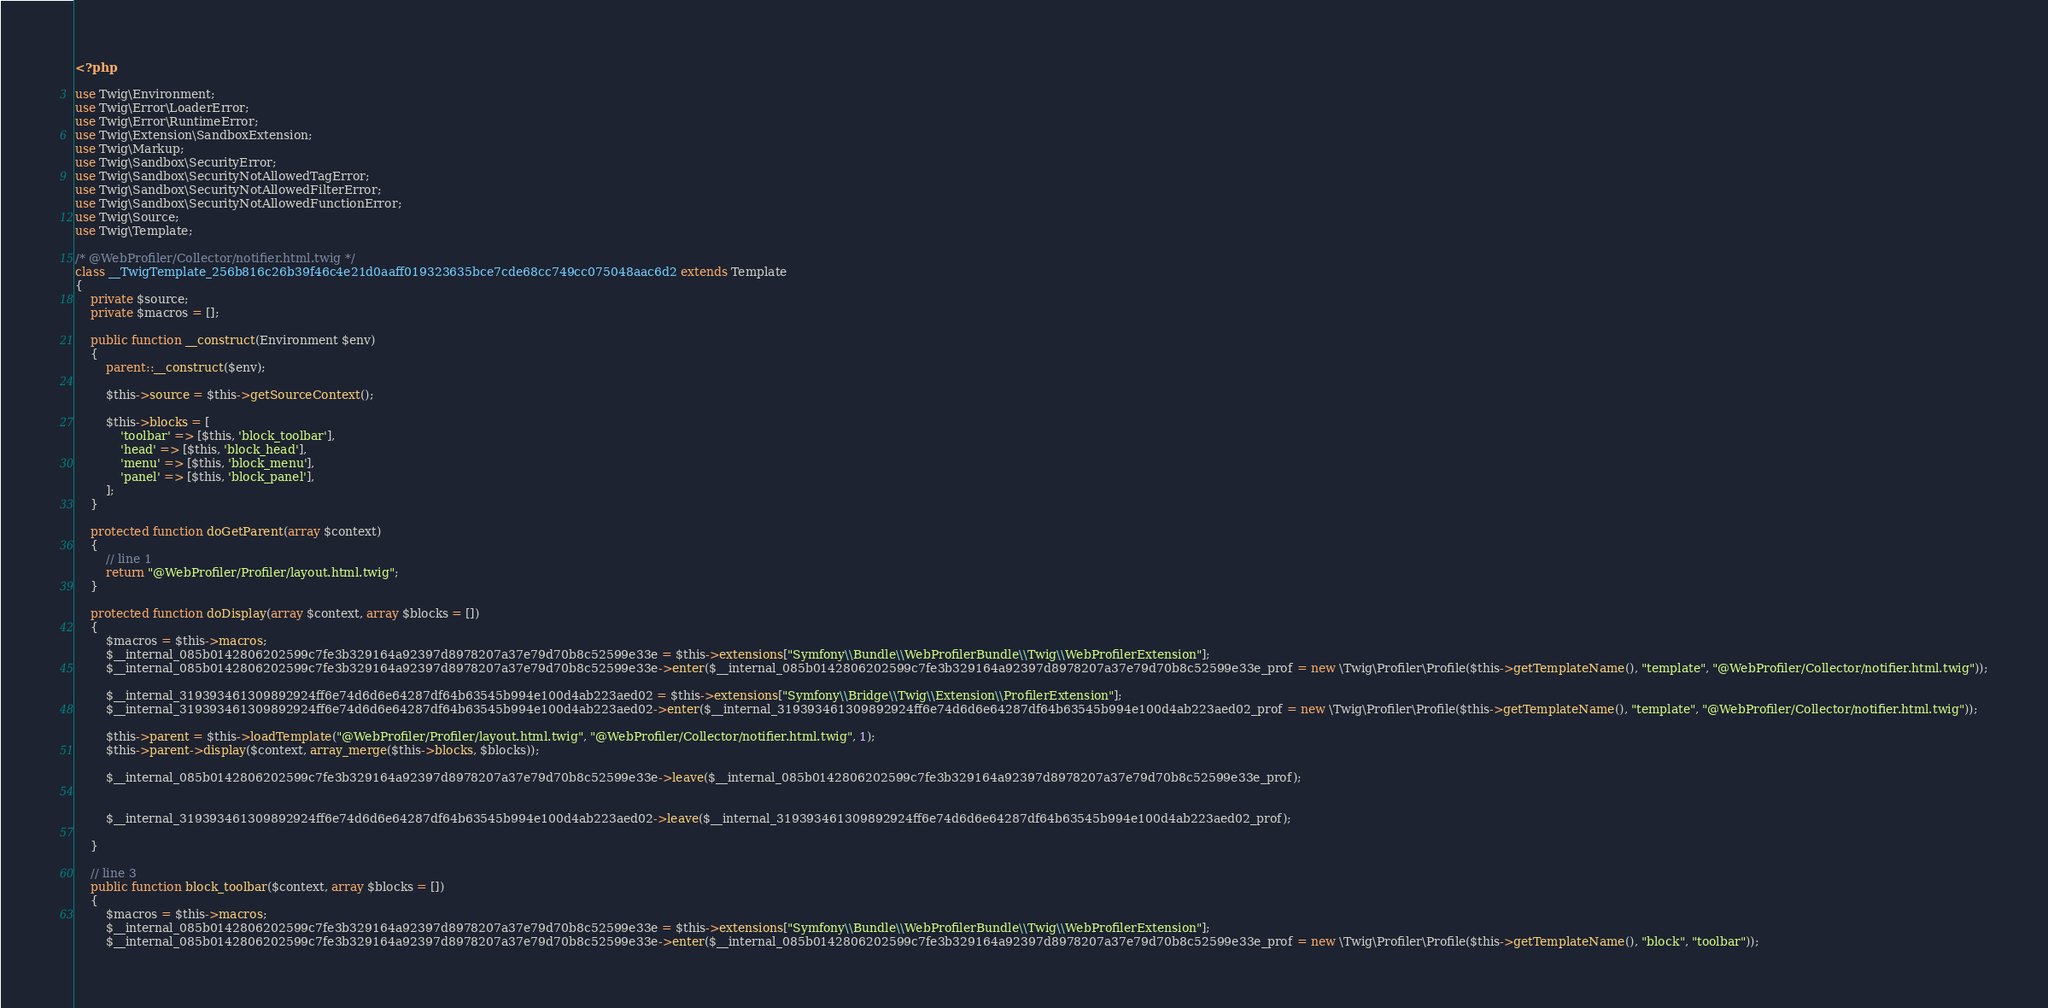Convert code to text. <code><loc_0><loc_0><loc_500><loc_500><_PHP_><?php

use Twig\Environment;
use Twig\Error\LoaderError;
use Twig\Error\RuntimeError;
use Twig\Extension\SandboxExtension;
use Twig\Markup;
use Twig\Sandbox\SecurityError;
use Twig\Sandbox\SecurityNotAllowedTagError;
use Twig\Sandbox\SecurityNotAllowedFilterError;
use Twig\Sandbox\SecurityNotAllowedFunctionError;
use Twig\Source;
use Twig\Template;

/* @WebProfiler/Collector/notifier.html.twig */
class __TwigTemplate_256b816c26b39f46c4e21d0aaff019323635bce7cde68cc749cc075048aac6d2 extends Template
{
    private $source;
    private $macros = [];

    public function __construct(Environment $env)
    {
        parent::__construct($env);

        $this->source = $this->getSourceContext();

        $this->blocks = [
            'toolbar' => [$this, 'block_toolbar'],
            'head' => [$this, 'block_head'],
            'menu' => [$this, 'block_menu'],
            'panel' => [$this, 'block_panel'],
        ];
    }

    protected function doGetParent(array $context)
    {
        // line 1
        return "@WebProfiler/Profiler/layout.html.twig";
    }

    protected function doDisplay(array $context, array $blocks = [])
    {
        $macros = $this->macros;
        $__internal_085b0142806202599c7fe3b329164a92397d8978207a37e79d70b8c52599e33e = $this->extensions["Symfony\\Bundle\\WebProfilerBundle\\Twig\\WebProfilerExtension"];
        $__internal_085b0142806202599c7fe3b329164a92397d8978207a37e79d70b8c52599e33e->enter($__internal_085b0142806202599c7fe3b329164a92397d8978207a37e79d70b8c52599e33e_prof = new \Twig\Profiler\Profile($this->getTemplateName(), "template", "@WebProfiler/Collector/notifier.html.twig"));

        $__internal_319393461309892924ff6e74d6d6e64287df64b63545b994e100d4ab223aed02 = $this->extensions["Symfony\\Bridge\\Twig\\Extension\\ProfilerExtension"];
        $__internal_319393461309892924ff6e74d6d6e64287df64b63545b994e100d4ab223aed02->enter($__internal_319393461309892924ff6e74d6d6e64287df64b63545b994e100d4ab223aed02_prof = new \Twig\Profiler\Profile($this->getTemplateName(), "template", "@WebProfiler/Collector/notifier.html.twig"));

        $this->parent = $this->loadTemplate("@WebProfiler/Profiler/layout.html.twig", "@WebProfiler/Collector/notifier.html.twig", 1);
        $this->parent->display($context, array_merge($this->blocks, $blocks));
        
        $__internal_085b0142806202599c7fe3b329164a92397d8978207a37e79d70b8c52599e33e->leave($__internal_085b0142806202599c7fe3b329164a92397d8978207a37e79d70b8c52599e33e_prof);

        
        $__internal_319393461309892924ff6e74d6d6e64287df64b63545b994e100d4ab223aed02->leave($__internal_319393461309892924ff6e74d6d6e64287df64b63545b994e100d4ab223aed02_prof);

    }

    // line 3
    public function block_toolbar($context, array $blocks = [])
    {
        $macros = $this->macros;
        $__internal_085b0142806202599c7fe3b329164a92397d8978207a37e79d70b8c52599e33e = $this->extensions["Symfony\\Bundle\\WebProfilerBundle\\Twig\\WebProfilerExtension"];
        $__internal_085b0142806202599c7fe3b329164a92397d8978207a37e79d70b8c52599e33e->enter($__internal_085b0142806202599c7fe3b329164a92397d8978207a37e79d70b8c52599e33e_prof = new \Twig\Profiler\Profile($this->getTemplateName(), "block", "toolbar"));
</code> 